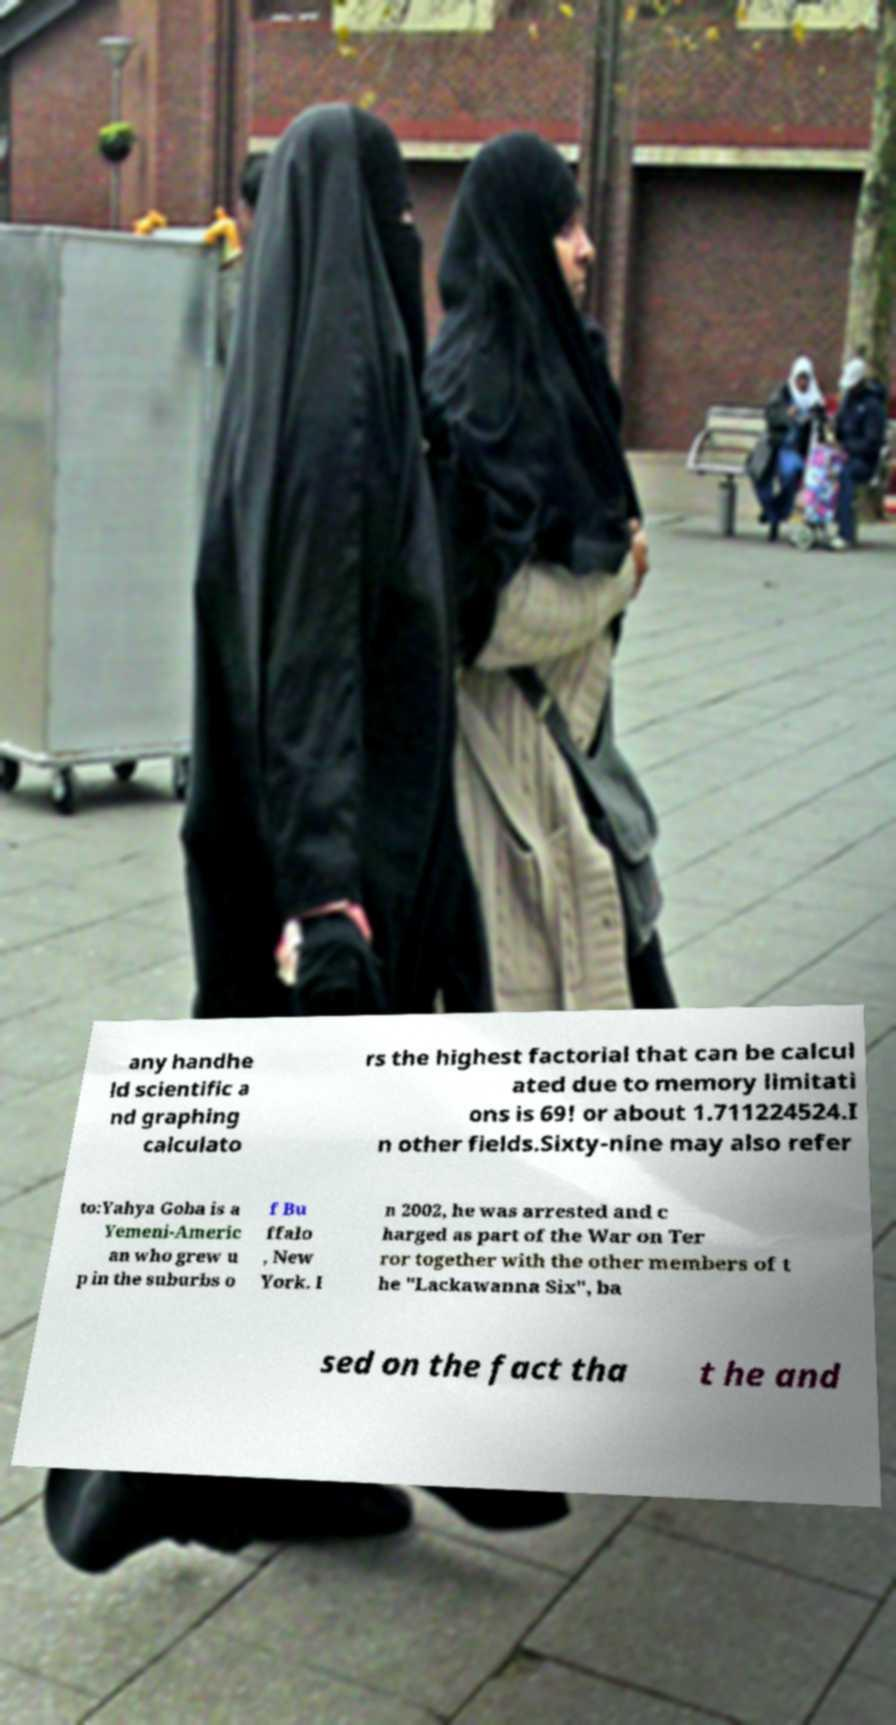Can you accurately transcribe the text from the provided image for me? any handhe ld scientific a nd graphing calculato rs the highest factorial that can be calcul ated due to memory limitati ons is 69! or about 1.711224524.I n other fields.Sixty-nine may also refer to:Yahya Goba is a Yemeni-Americ an who grew u p in the suburbs o f Bu ffalo , New York. I n 2002, he was arrested and c harged as part of the War on Ter ror together with the other members of t he "Lackawanna Six", ba sed on the fact tha t he and 